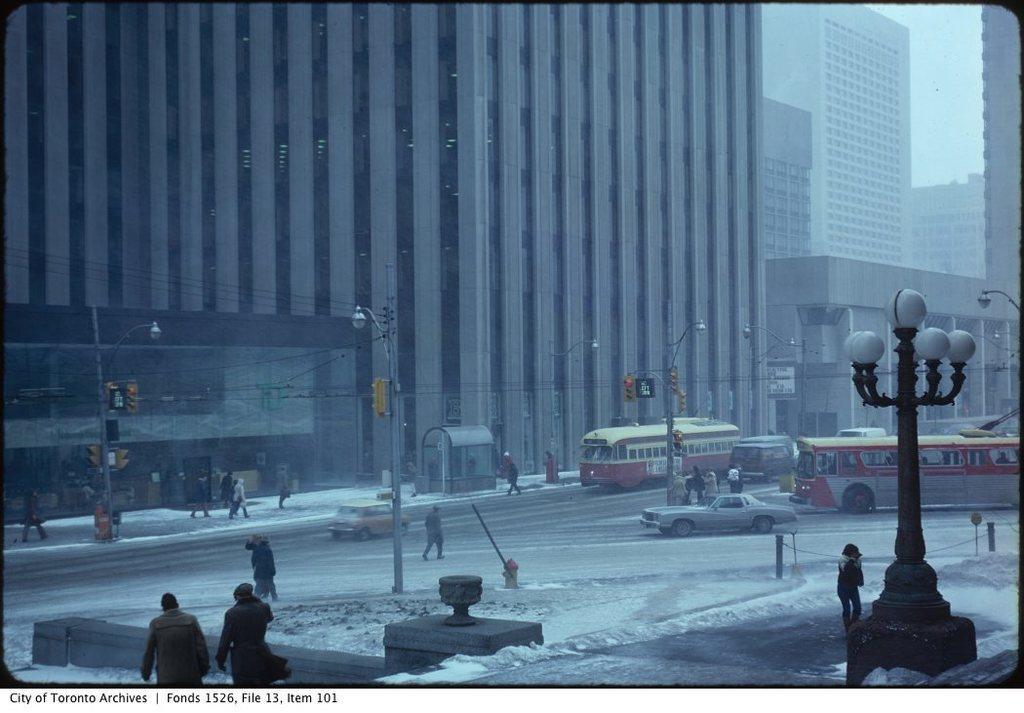Describe this image in one or two sentences. In this image we can see a group of vehicles, the snow and a group of people standing on the road. We can also see some street poles, a fence, the signboards, the traffic signal, some wires, a group of buildings and the sky which looks cloudy. 